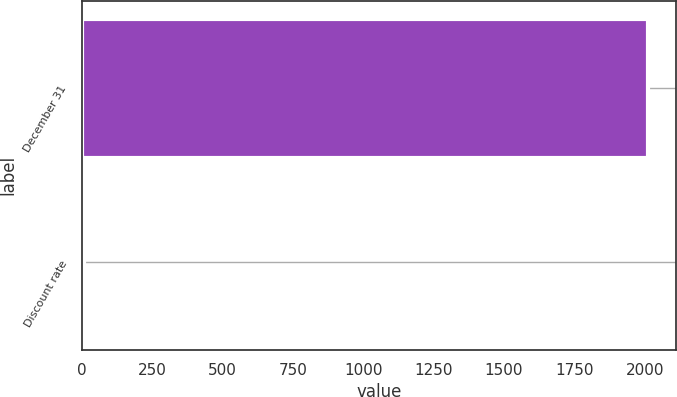<chart> <loc_0><loc_0><loc_500><loc_500><bar_chart><fcel>December 31<fcel>Discount rate<nl><fcel>2010<fcel>5.5<nl></chart> 